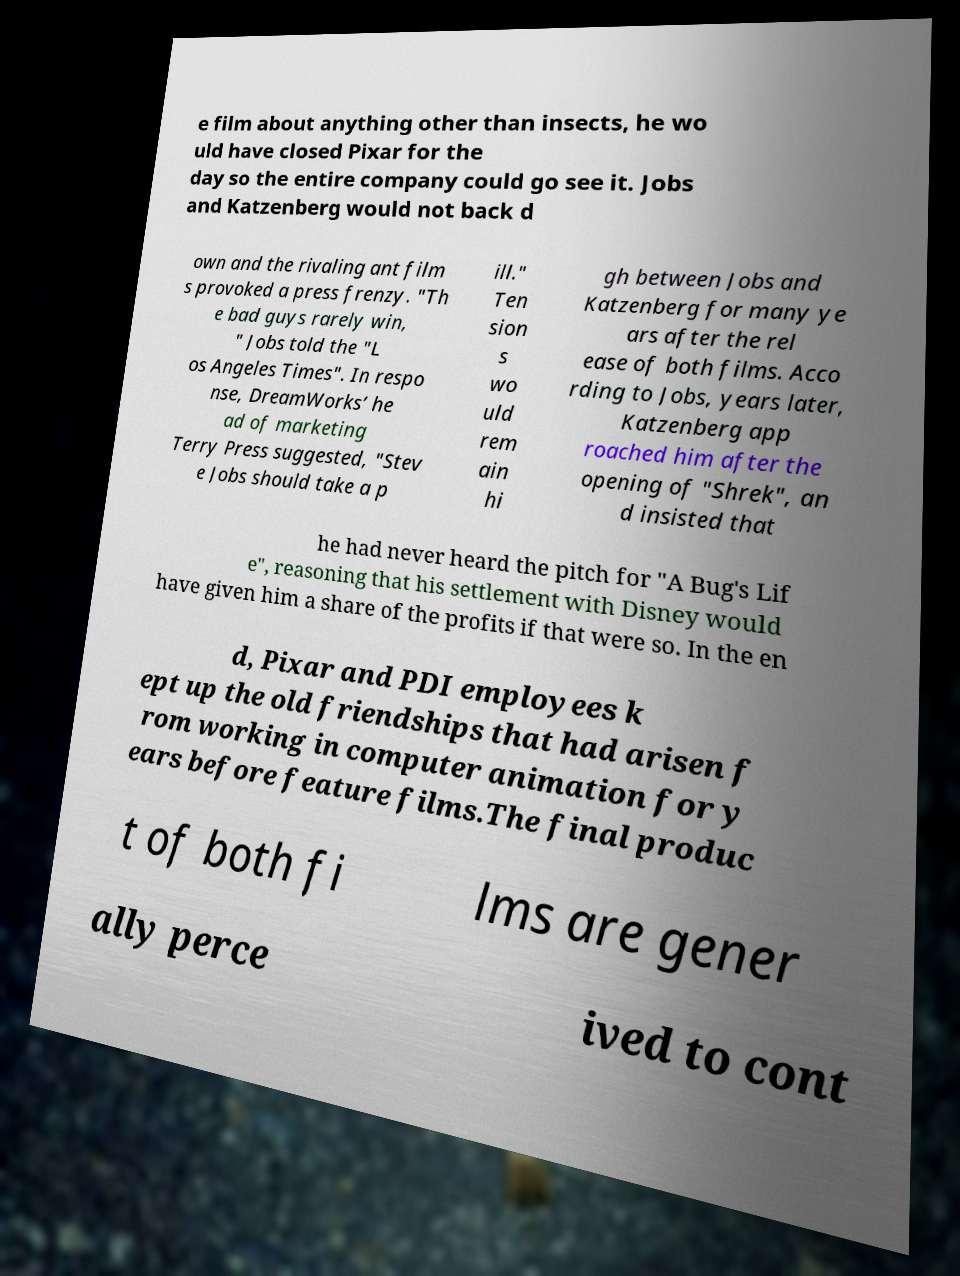For documentation purposes, I need the text within this image transcribed. Could you provide that? e film about anything other than insects, he wo uld have closed Pixar for the day so the entire company could go see it. Jobs and Katzenberg would not back d own and the rivaling ant film s provoked a press frenzy. "Th e bad guys rarely win, " Jobs told the "L os Angeles Times". In respo nse, DreamWorks’ he ad of marketing Terry Press suggested, "Stev e Jobs should take a p ill." Ten sion s wo uld rem ain hi gh between Jobs and Katzenberg for many ye ars after the rel ease of both films. Acco rding to Jobs, years later, Katzenberg app roached him after the opening of "Shrek", an d insisted that he had never heard the pitch for "A Bug's Lif e", reasoning that his settlement with Disney would have given him a share of the profits if that were so. In the en d, Pixar and PDI employees k ept up the old friendships that had arisen f rom working in computer animation for y ears before feature films.The final produc t of both fi lms are gener ally perce ived to cont 